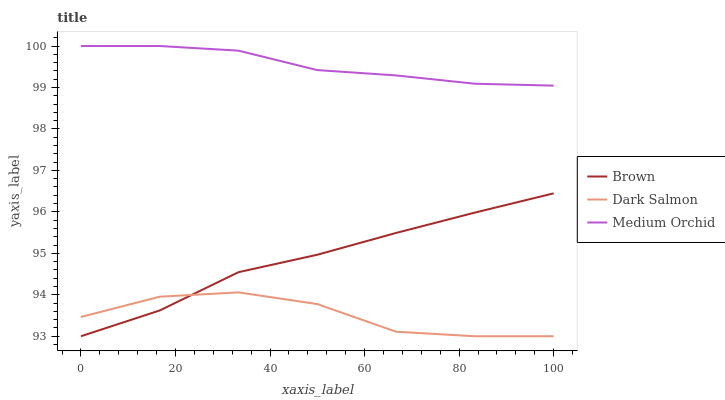Does Dark Salmon have the minimum area under the curve?
Answer yes or no. Yes. Does Medium Orchid have the maximum area under the curve?
Answer yes or no. Yes. Does Medium Orchid have the minimum area under the curve?
Answer yes or no. No. Does Dark Salmon have the maximum area under the curve?
Answer yes or no. No. Is Brown the smoothest?
Answer yes or no. Yes. Is Dark Salmon the roughest?
Answer yes or no. Yes. Is Medium Orchid the smoothest?
Answer yes or no. No. Is Medium Orchid the roughest?
Answer yes or no. No. Does Medium Orchid have the lowest value?
Answer yes or no. No. Does Medium Orchid have the highest value?
Answer yes or no. Yes. Does Dark Salmon have the highest value?
Answer yes or no. No. Is Brown less than Medium Orchid?
Answer yes or no. Yes. Is Medium Orchid greater than Dark Salmon?
Answer yes or no. Yes. Does Dark Salmon intersect Brown?
Answer yes or no. Yes. Is Dark Salmon less than Brown?
Answer yes or no. No. Is Dark Salmon greater than Brown?
Answer yes or no. No. Does Brown intersect Medium Orchid?
Answer yes or no. No. 